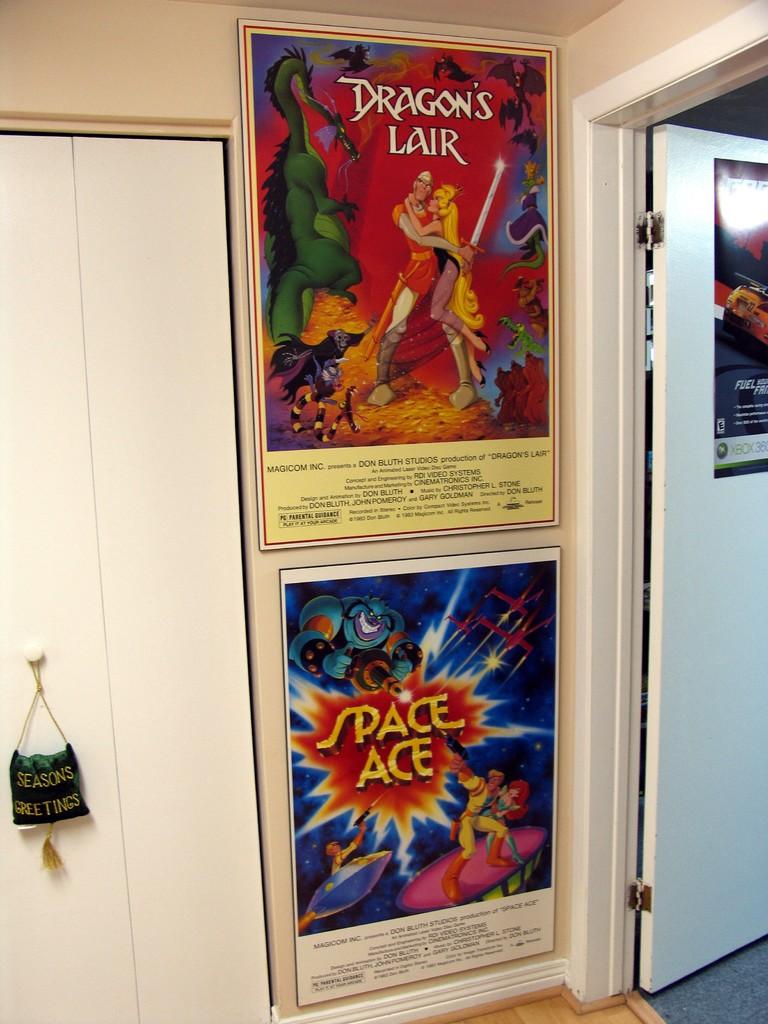What game is advertised on the bottom poster?
Your answer should be very brief. Space ace. 